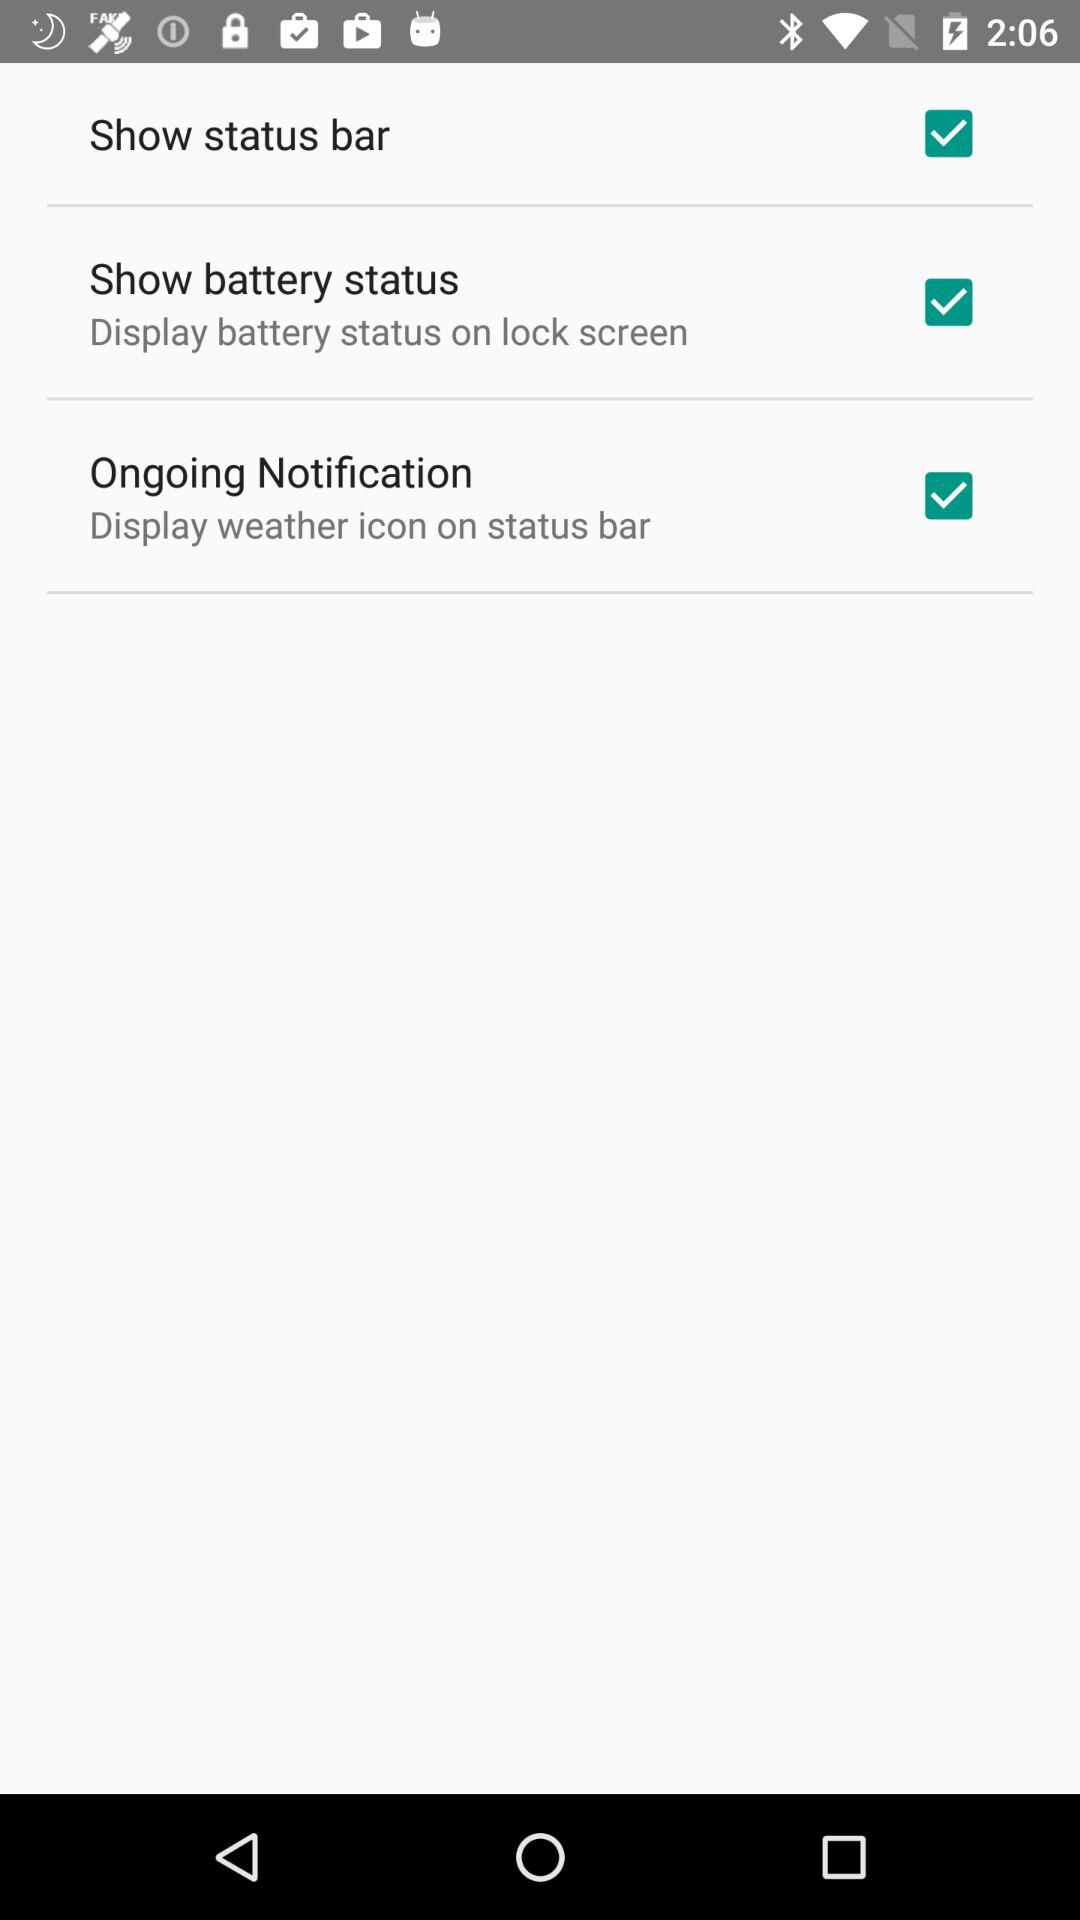What is the location of the batter status?
When the provided information is insufficient, respond with <no answer>. <no answer> 